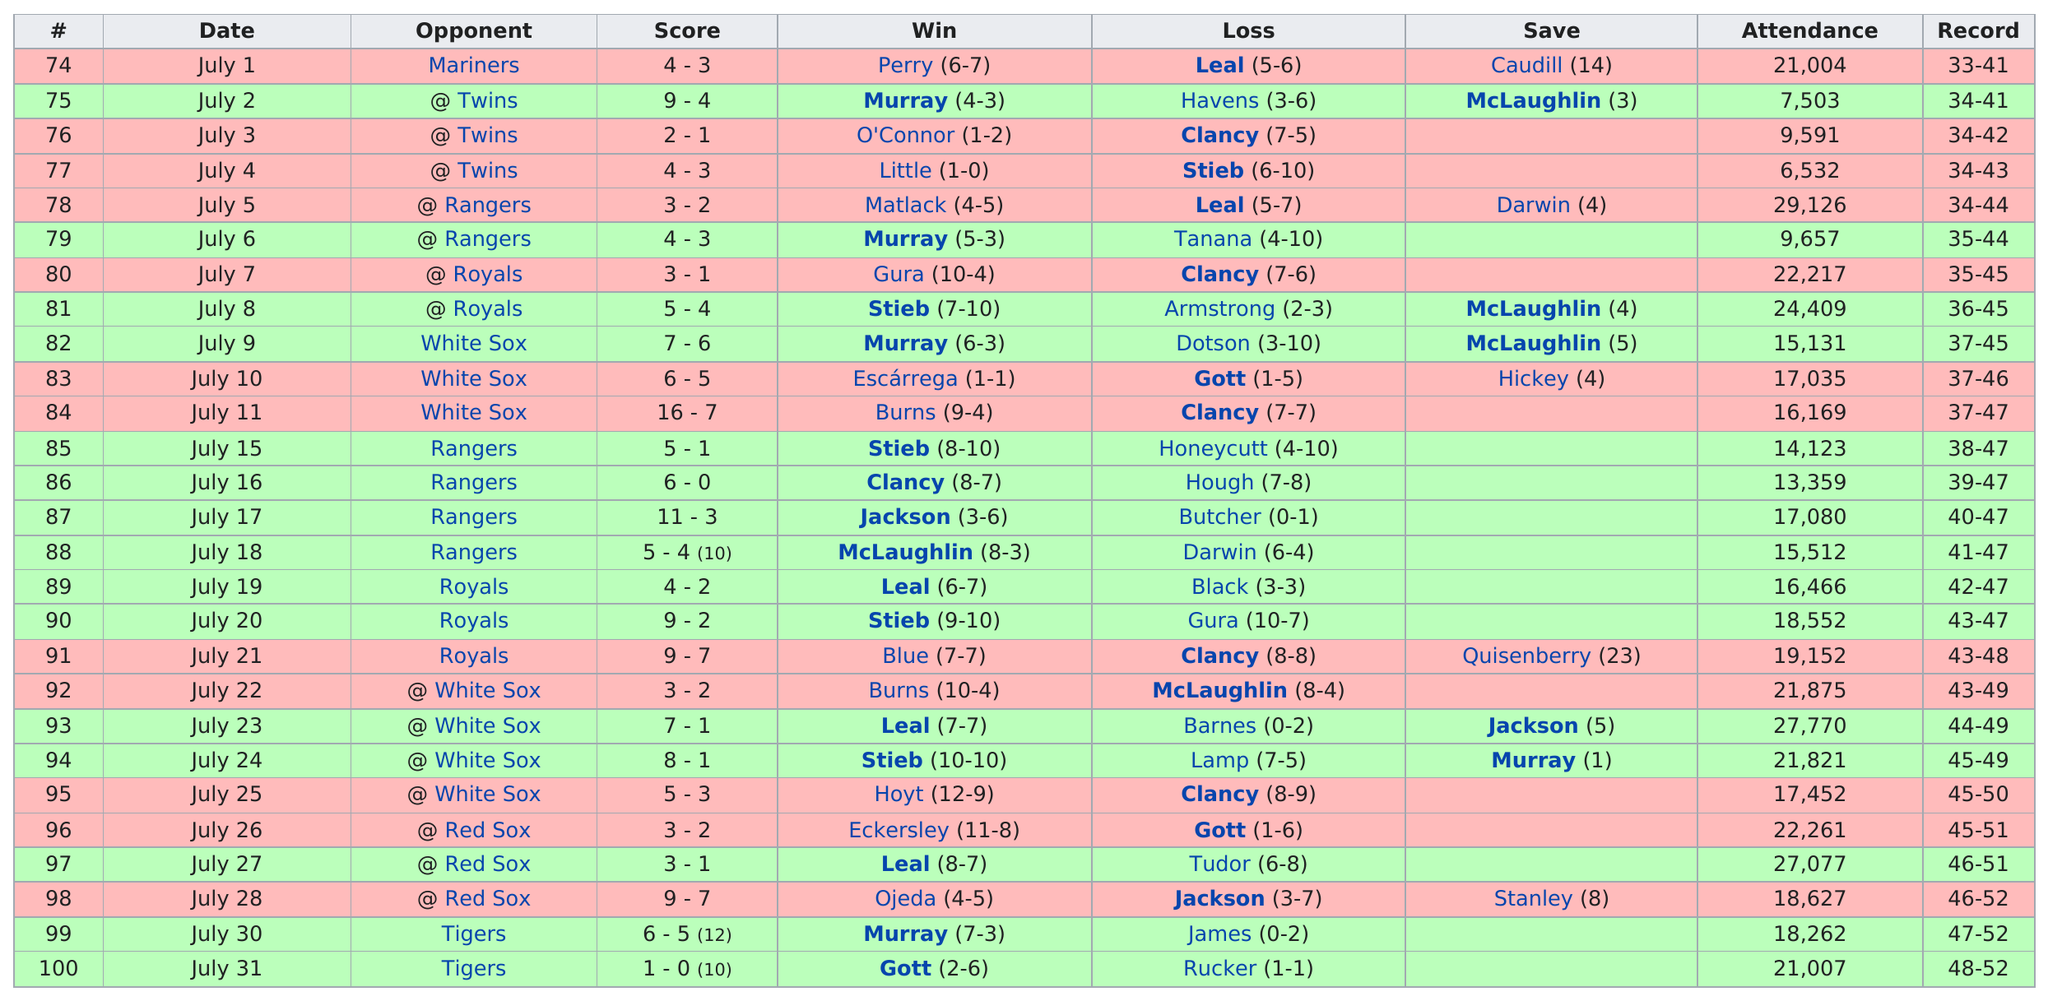Identify some key points in this picture. On July 7, there was an attendance of 2192. On July 8, there was a difference in attendance of 2192. The lowest scoring win for them occurred on July 31. After July 6, when was the next time Murray scored a win? The answer is July 9. The Blue Jays played 27 games in the month of July. I, leal, triumphed on July 23, but alas, my noble Blue Jays had not prevailed since July 20, a sorrowful period of defeat. 